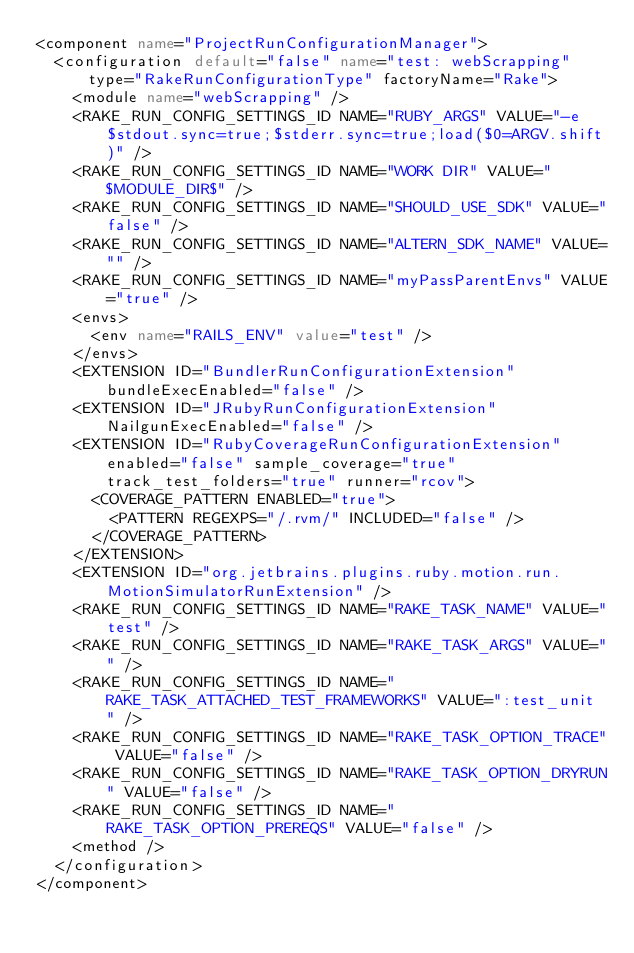Convert code to text. <code><loc_0><loc_0><loc_500><loc_500><_XML_><component name="ProjectRunConfigurationManager">
  <configuration default="false" name="test: webScrapping" type="RakeRunConfigurationType" factoryName="Rake">
    <module name="webScrapping" />
    <RAKE_RUN_CONFIG_SETTINGS_ID NAME="RUBY_ARGS" VALUE="-e $stdout.sync=true;$stderr.sync=true;load($0=ARGV.shift)" />
    <RAKE_RUN_CONFIG_SETTINGS_ID NAME="WORK DIR" VALUE="$MODULE_DIR$" />
    <RAKE_RUN_CONFIG_SETTINGS_ID NAME="SHOULD_USE_SDK" VALUE="false" />
    <RAKE_RUN_CONFIG_SETTINGS_ID NAME="ALTERN_SDK_NAME" VALUE="" />
    <RAKE_RUN_CONFIG_SETTINGS_ID NAME="myPassParentEnvs" VALUE="true" />
    <envs>
      <env name="RAILS_ENV" value="test" />
    </envs>
    <EXTENSION ID="BundlerRunConfigurationExtension" bundleExecEnabled="false" />
    <EXTENSION ID="JRubyRunConfigurationExtension" NailgunExecEnabled="false" />
    <EXTENSION ID="RubyCoverageRunConfigurationExtension" enabled="false" sample_coverage="true" track_test_folders="true" runner="rcov">
      <COVERAGE_PATTERN ENABLED="true">
        <PATTERN REGEXPS="/.rvm/" INCLUDED="false" />
      </COVERAGE_PATTERN>
    </EXTENSION>
    <EXTENSION ID="org.jetbrains.plugins.ruby.motion.run.MotionSimulatorRunExtension" />
    <RAKE_RUN_CONFIG_SETTINGS_ID NAME="RAKE_TASK_NAME" VALUE="test" />
    <RAKE_RUN_CONFIG_SETTINGS_ID NAME="RAKE_TASK_ARGS" VALUE="" />
    <RAKE_RUN_CONFIG_SETTINGS_ID NAME="RAKE_TASK_ATTACHED_TEST_FRAMEWORKS" VALUE=":test_unit " />
    <RAKE_RUN_CONFIG_SETTINGS_ID NAME="RAKE_TASK_OPTION_TRACE" VALUE="false" />
    <RAKE_RUN_CONFIG_SETTINGS_ID NAME="RAKE_TASK_OPTION_DRYRUN" VALUE="false" />
    <RAKE_RUN_CONFIG_SETTINGS_ID NAME="RAKE_TASK_OPTION_PREREQS" VALUE="false" />
    <method />
  </configuration>
</component></code> 